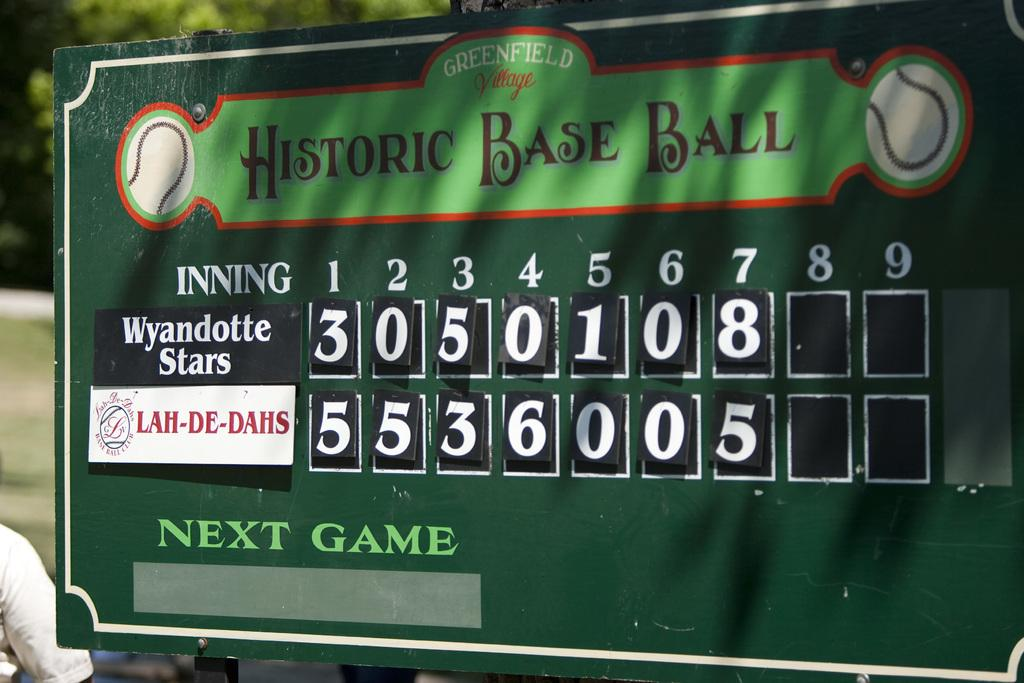Provide a one-sentence caption for the provided image. A green scoreboard of a baseball game showing a play between the Wyandotte Stars and the Lah-De-Dahs. 